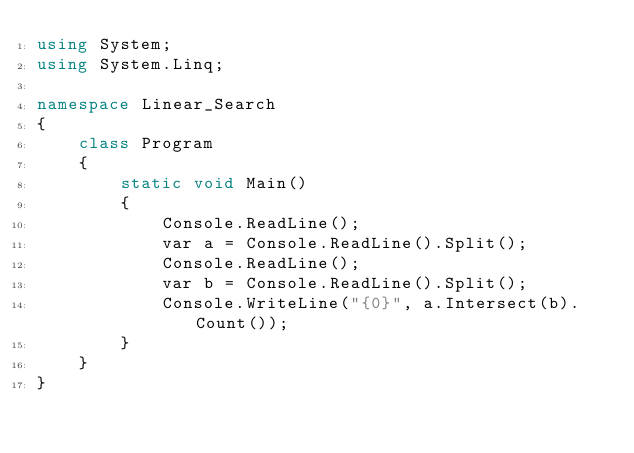Convert code to text. <code><loc_0><loc_0><loc_500><loc_500><_C#_>using System;
using System.Linq;

namespace Linear_Search
{
    class Program
    {
        static void Main()
        {
            Console.ReadLine();
            var a = Console.ReadLine().Split();
            Console.ReadLine();
            var b = Console.ReadLine().Split();
            Console.WriteLine("{0}", a.Intersect(b).Count());
        }
    }
}</code> 